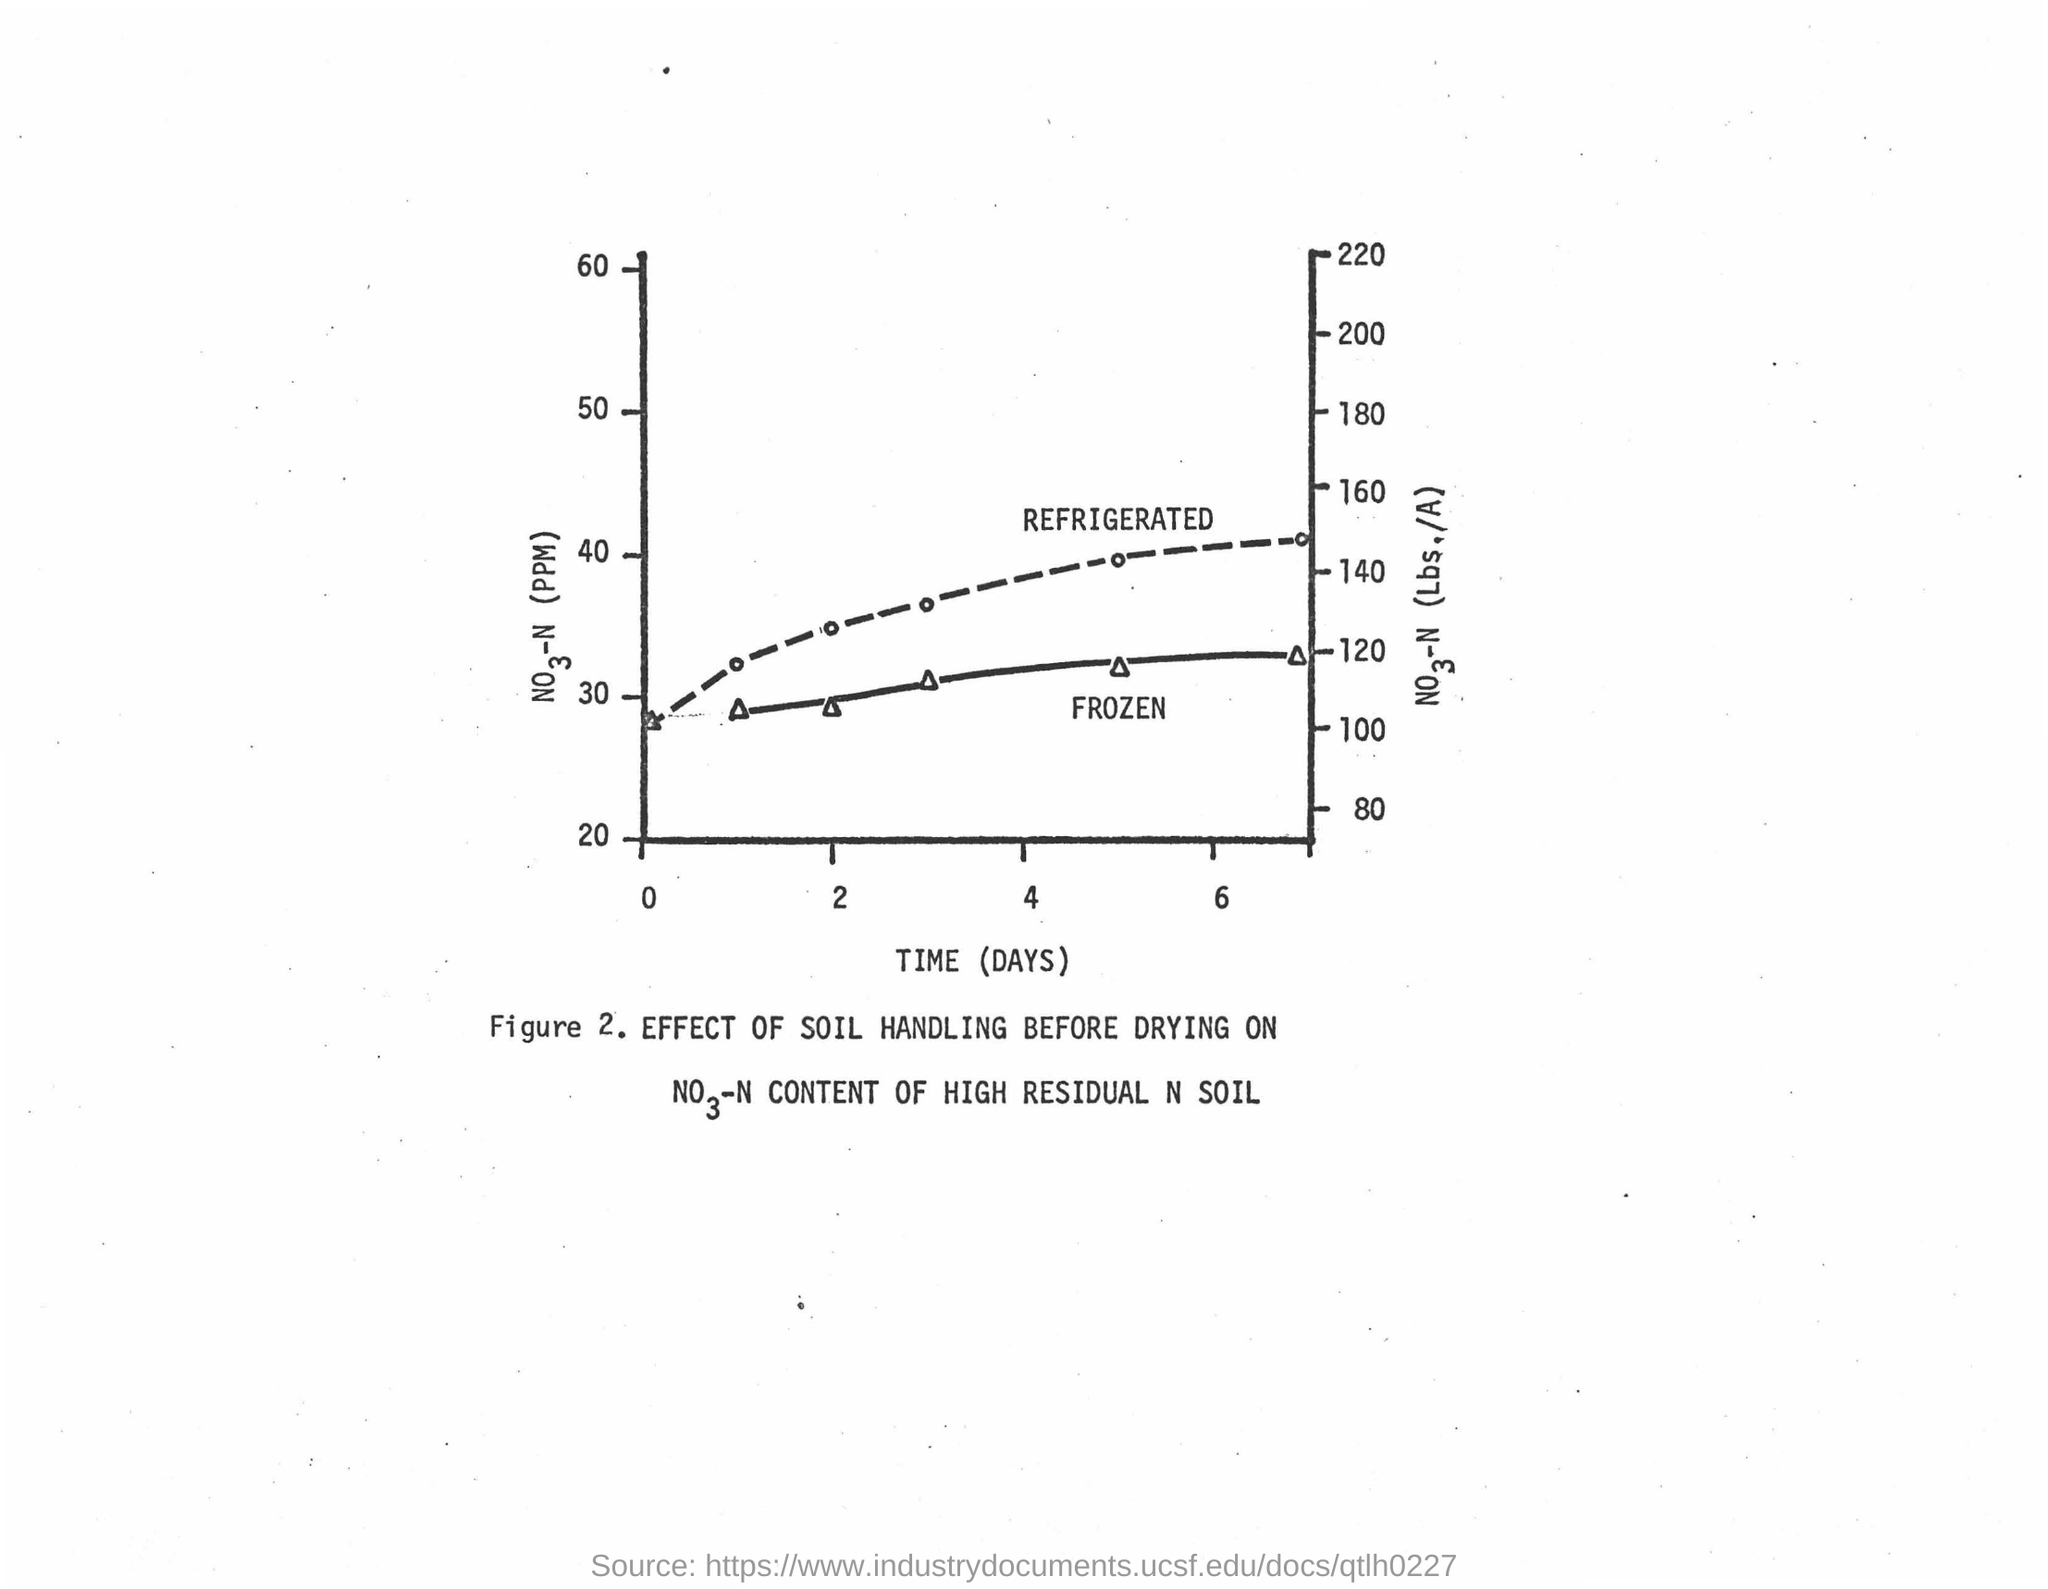What is plotted in the x-axis ?
Ensure brevity in your answer.  Time (Days). 